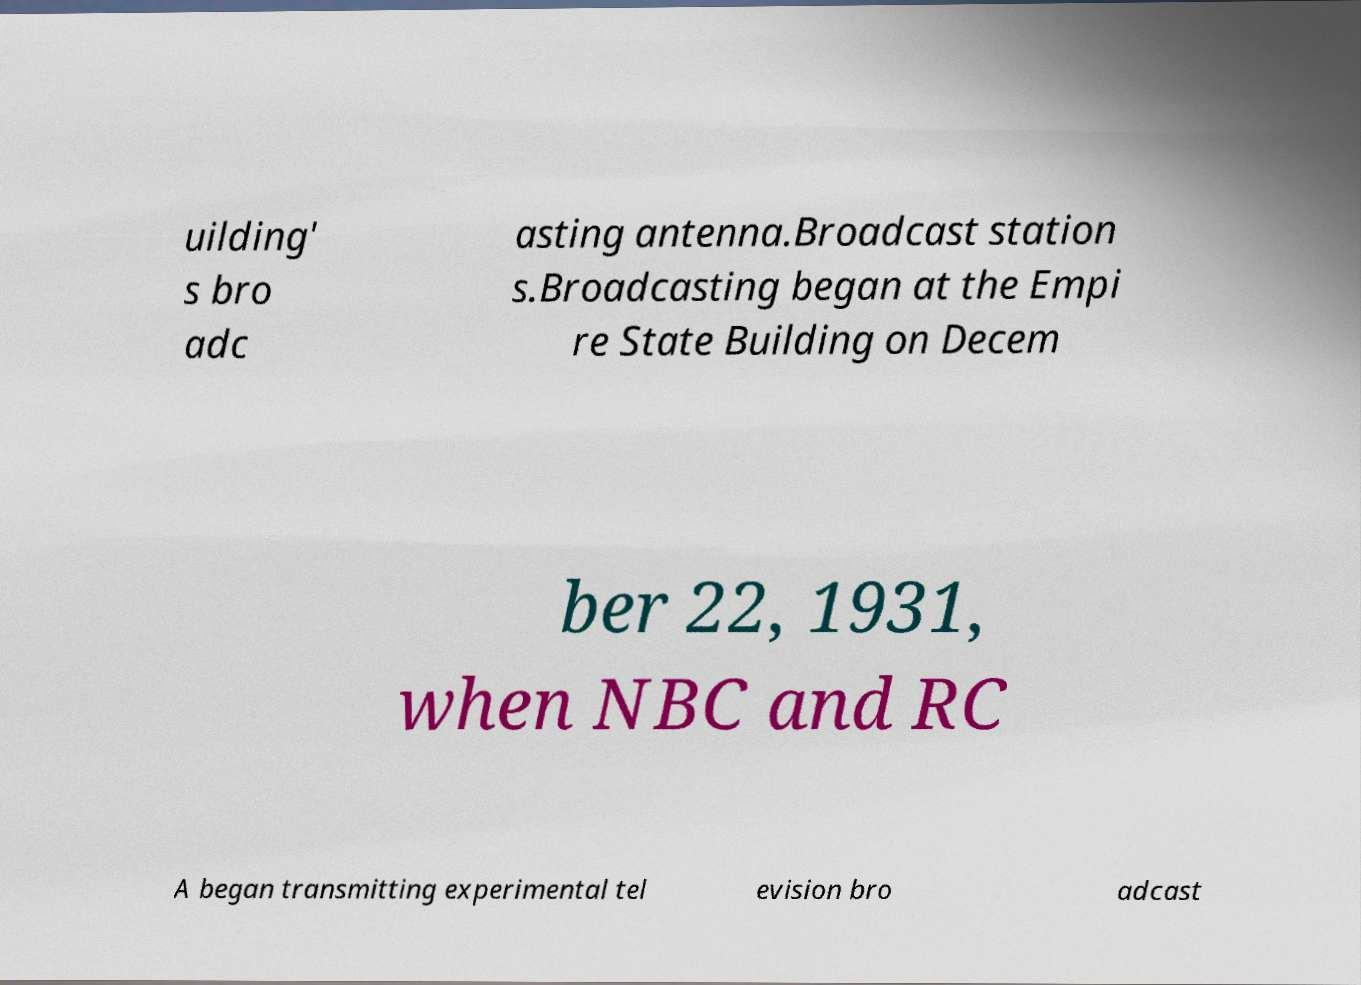Please read and relay the text visible in this image. What does it say? uilding' s bro adc asting antenna.Broadcast station s.Broadcasting began at the Empi re State Building on Decem ber 22, 1931, when NBC and RC A began transmitting experimental tel evision bro adcast 